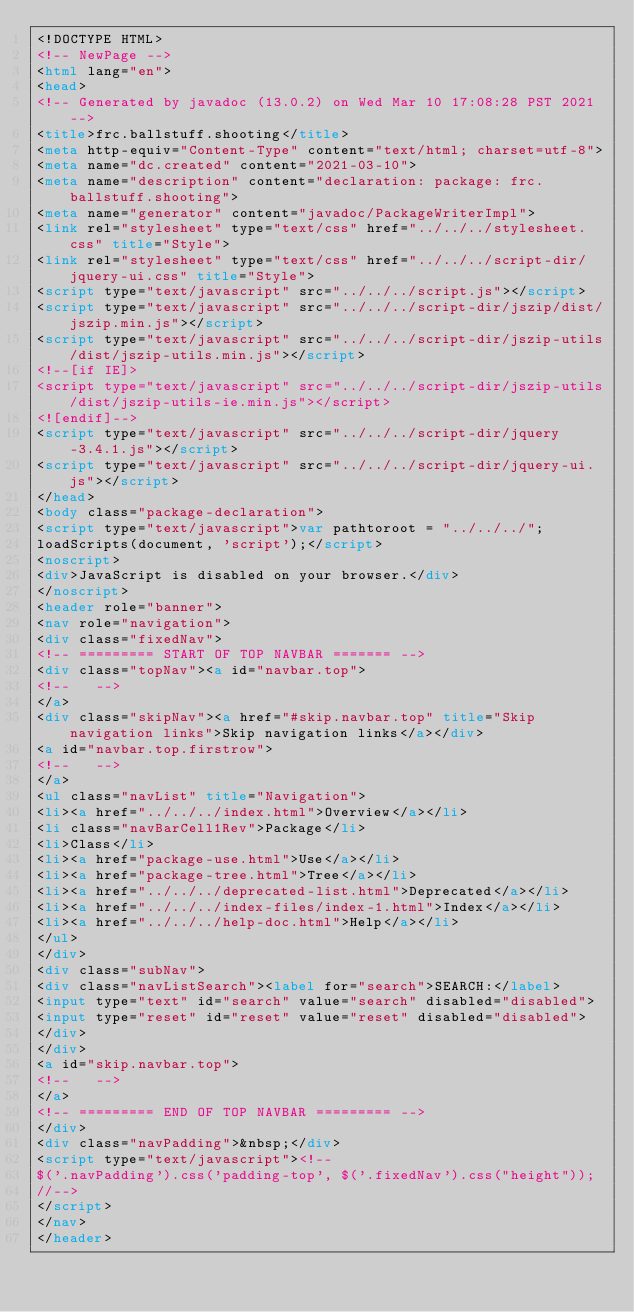Convert code to text. <code><loc_0><loc_0><loc_500><loc_500><_HTML_><!DOCTYPE HTML>
<!-- NewPage -->
<html lang="en">
<head>
<!-- Generated by javadoc (13.0.2) on Wed Mar 10 17:08:28 PST 2021 -->
<title>frc.ballstuff.shooting</title>
<meta http-equiv="Content-Type" content="text/html; charset=utf-8">
<meta name="dc.created" content="2021-03-10">
<meta name="description" content="declaration: package: frc.ballstuff.shooting">
<meta name="generator" content="javadoc/PackageWriterImpl">
<link rel="stylesheet" type="text/css" href="../../../stylesheet.css" title="Style">
<link rel="stylesheet" type="text/css" href="../../../script-dir/jquery-ui.css" title="Style">
<script type="text/javascript" src="../../../script.js"></script>
<script type="text/javascript" src="../../../script-dir/jszip/dist/jszip.min.js"></script>
<script type="text/javascript" src="../../../script-dir/jszip-utils/dist/jszip-utils.min.js"></script>
<!--[if IE]>
<script type="text/javascript" src="../../../script-dir/jszip-utils/dist/jszip-utils-ie.min.js"></script>
<![endif]-->
<script type="text/javascript" src="../../../script-dir/jquery-3.4.1.js"></script>
<script type="text/javascript" src="../../../script-dir/jquery-ui.js"></script>
</head>
<body class="package-declaration">
<script type="text/javascript">var pathtoroot = "../../../";
loadScripts(document, 'script');</script>
<noscript>
<div>JavaScript is disabled on your browser.</div>
</noscript>
<header role="banner">
<nav role="navigation">
<div class="fixedNav">
<!-- ========= START OF TOP NAVBAR ======= -->
<div class="topNav"><a id="navbar.top">
<!--   -->
</a>
<div class="skipNav"><a href="#skip.navbar.top" title="Skip navigation links">Skip navigation links</a></div>
<a id="navbar.top.firstrow">
<!--   -->
</a>
<ul class="navList" title="Navigation">
<li><a href="../../../index.html">Overview</a></li>
<li class="navBarCell1Rev">Package</li>
<li>Class</li>
<li><a href="package-use.html">Use</a></li>
<li><a href="package-tree.html">Tree</a></li>
<li><a href="../../../deprecated-list.html">Deprecated</a></li>
<li><a href="../../../index-files/index-1.html">Index</a></li>
<li><a href="../../../help-doc.html">Help</a></li>
</ul>
</div>
<div class="subNav">
<div class="navListSearch"><label for="search">SEARCH:</label>
<input type="text" id="search" value="search" disabled="disabled">
<input type="reset" id="reset" value="reset" disabled="disabled">
</div>
</div>
<a id="skip.navbar.top">
<!--   -->
</a>
<!-- ========= END OF TOP NAVBAR ========= -->
</div>
<div class="navPadding">&nbsp;</div>
<script type="text/javascript"><!--
$('.navPadding').css('padding-top', $('.fixedNav').css("height"));
//-->
</script>
</nav>
</header></code> 